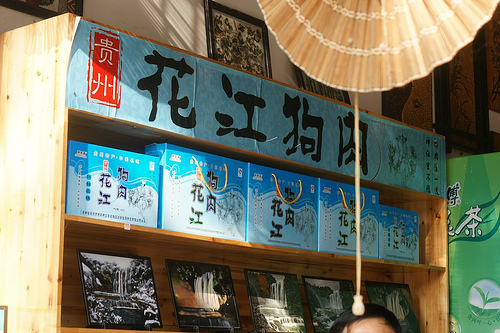<image>
Is the cord in front of the head? Yes. The cord is positioned in front of the head, appearing closer to the camera viewpoint. 